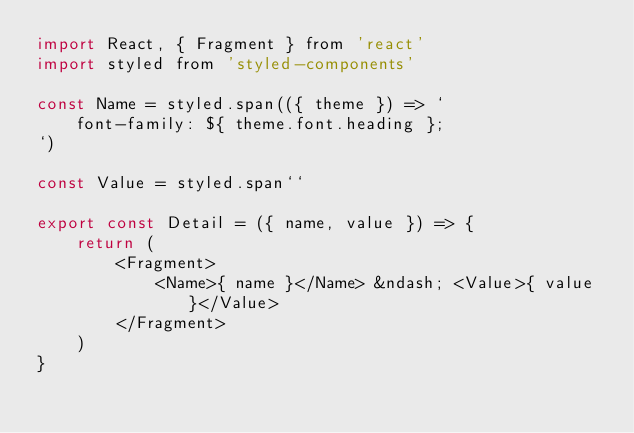<code> <loc_0><loc_0><loc_500><loc_500><_JavaScript_>import React, { Fragment } from 'react'
import styled from 'styled-components'

const Name = styled.span(({ theme }) => `
    font-family: ${ theme.font.heading }; 
`)

const Value = styled.span``

export const Detail = ({ name, value }) => {
    return (
        <Fragment>
            <Name>{ name }</Name> &ndash; <Value>{ value }</Value>
        </Fragment>
    )
}
</code> 